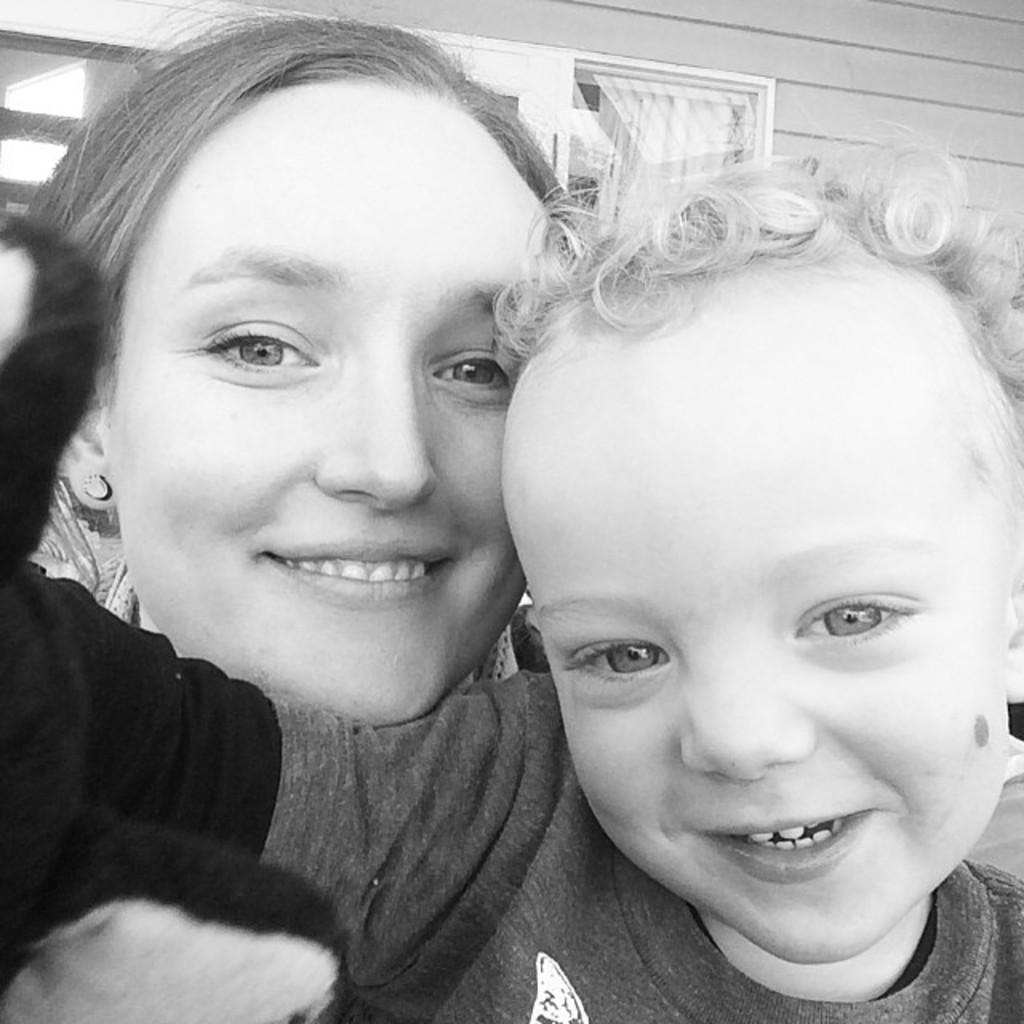Who is present in the image? There is a boy and a woman in the image. What are the facial expressions of the individuals in the image? The boy and the woman are both smiling. What can be seen in the background of the image? There is a building in the background of the image. What type of coal is being used to heat the property in the image? There is no coal or property present in the image; it features a boy and a woman smiling, with a building in the background. 